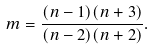<formula> <loc_0><loc_0><loc_500><loc_500>m = \frac { ( n - 1 ) ( n + 3 ) } { ( n - 2 ) ( n + 2 ) } .</formula> 